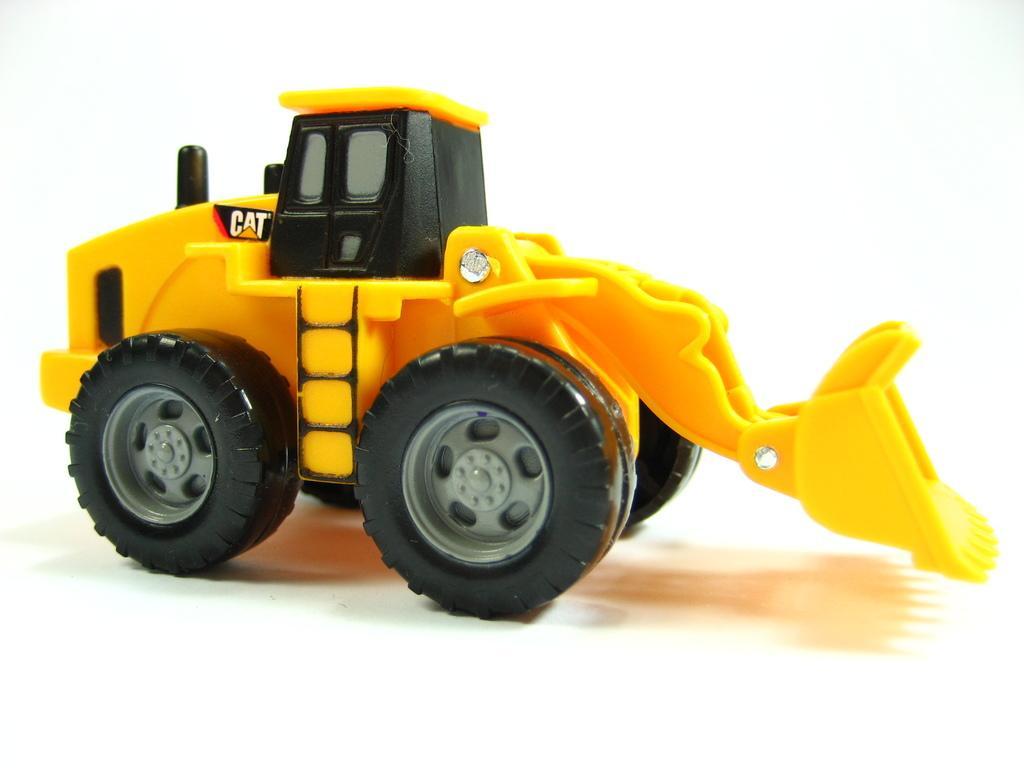In one or two sentences, can you explain what this image depicts? In this image we can see a toy excavator. 